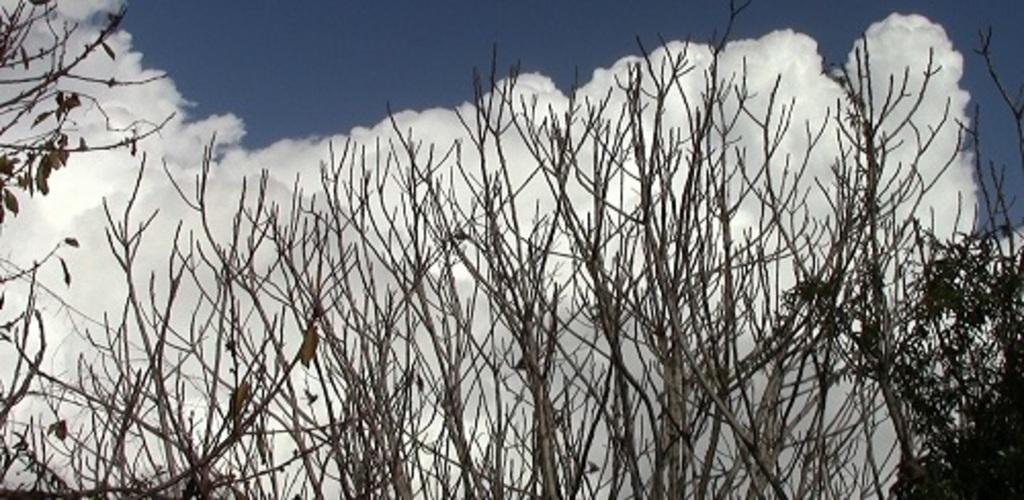Please provide a concise description of this image. In this image we can see trees and sky with clouds in the background. 